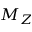<formula> <loc_0><loc_0><loc_500><loc_500>M _ { Z }</formula> 